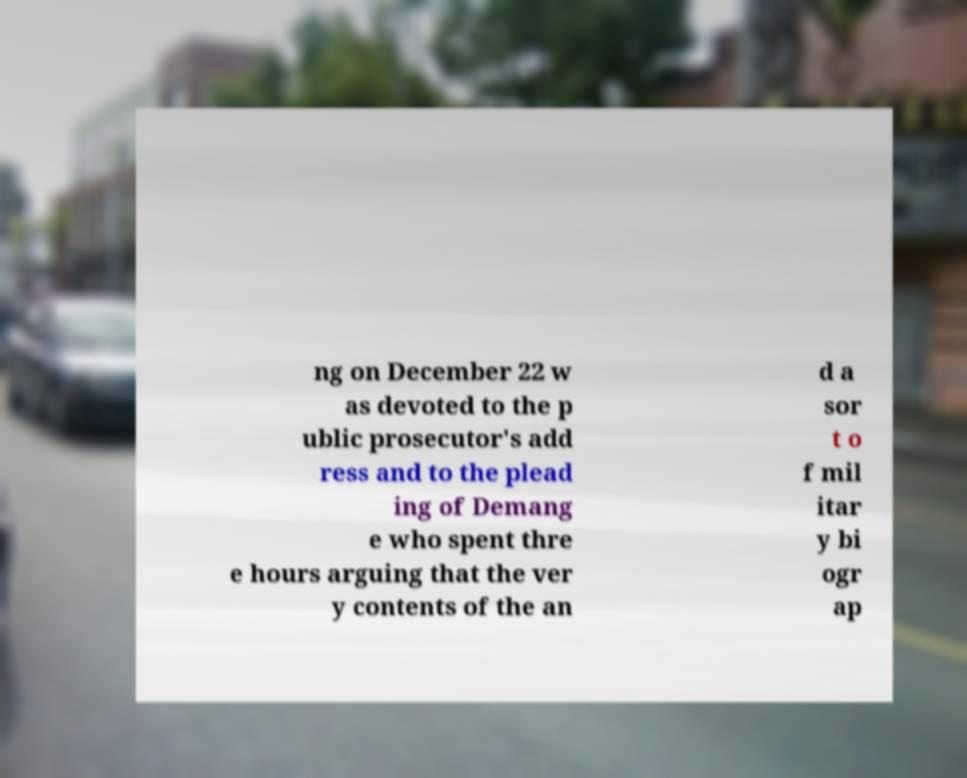For documentation purposes, I need the text within this image transcribed. Could you provide that? ng on December 22 w as devoted to the p ublic prosecutor's add ress and to the plead ing of Demang e who spent thre e hours arguing that the ver y contents of the an d a sor t o f mil itar y bi ogr ap 